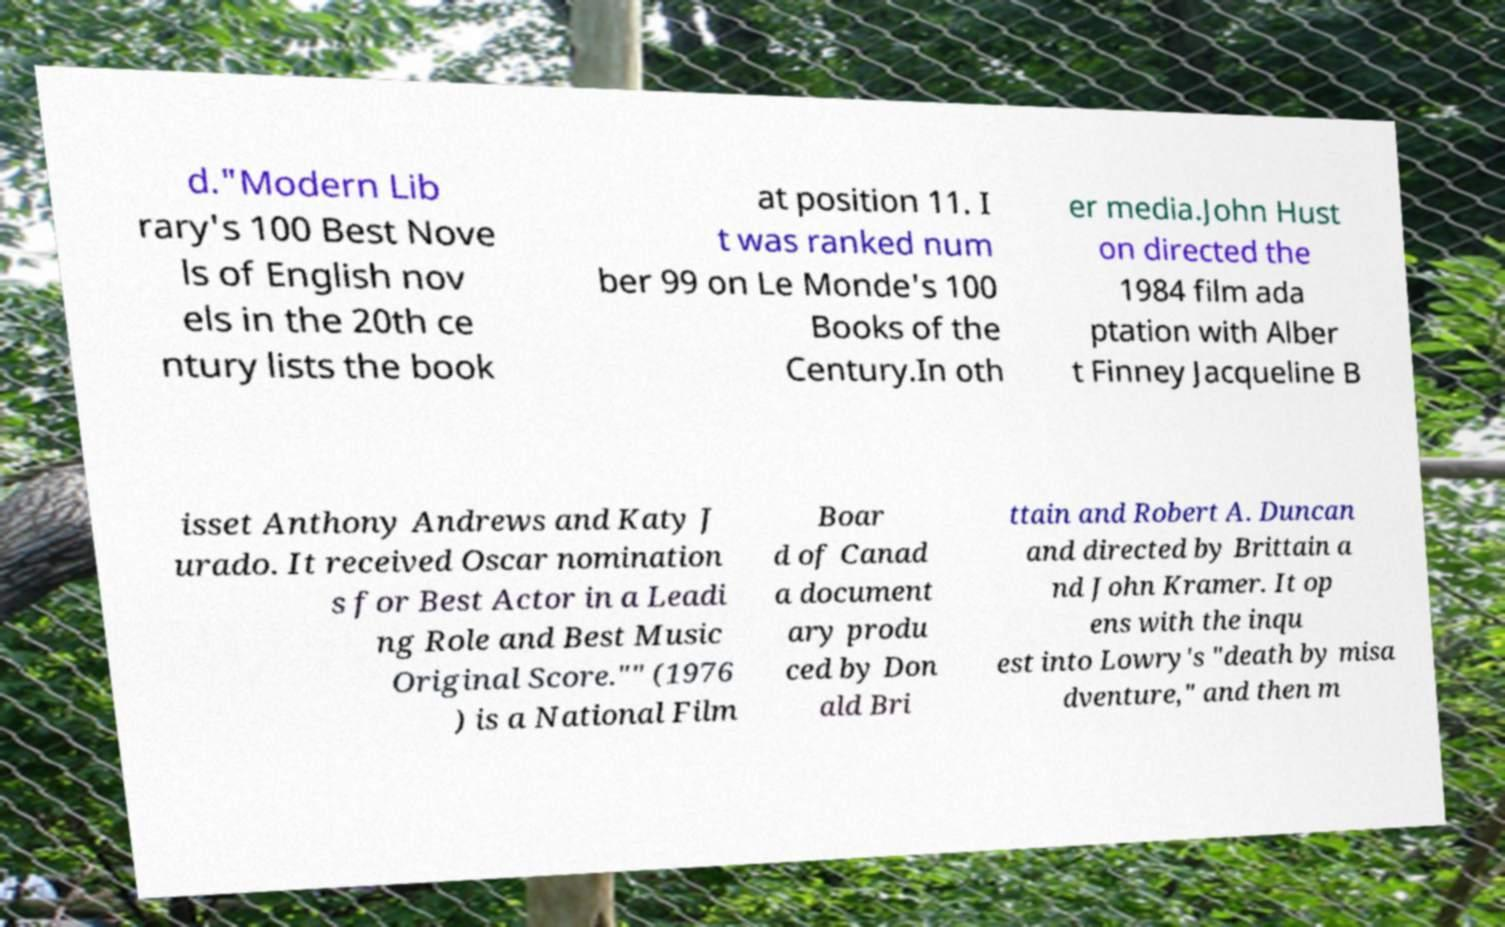What messages or text are displayed in this image? I need them in a readable, typed format. d."Modern Lib rary's 100 Best Nove ls of English nov els in the 20th ce ntury lists the book at position 11. I t was ranked num ber 99 on Le Monde's 100 Books of the Century.In oth er media.John Hust on directed the 1984 film ada ptation with Alber t Finney Jacqueline B isset Anthony Andrews and Katy J urado. It received Oscar nomination s for Best Actor in a Leadi ng Role and Best Music Original Score."" (1976 ) is a National Film Boar d of Canad a document ary produ ced by Don ald Bri ttain and Robert A. Duncan and directed by Brittain a nd John Kramer. It op ens with the inqu est into Lowry's "death by misa dventure," and then m 